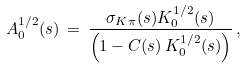Convert formula to latex. <formula><loc_0><loc_0><loc_500><loc_500>A _ { 0 } ^ { 1 / 2 } ( s ) \, = \, \frac { \sigma _ { K \pi } ( s ) K _ { 0 } ^ { 1 / 2 } ( s ) } { \left ( 1 - C ( s ) \, K _ { 0 } ^ { 1 / 2 } ( s ) \right ) } \, ,</formula> 